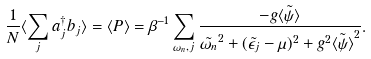<formula> <loc_0><loc_0><loc_500><loc_500>\frac { 1 } { N } \langle \sum _ { j } a ^ { \dagger } _ { j } b _ { j } \rangle = \langle P \rangle = \beta ^ { - 1 } \sum _ { \omega _ { n } , j } \frac { - g \tilde { \langle \psi \rangle } } { \tilde { \omega _ { n } } ^ { 2 } + ( \tilde { \epsilon _ { j } } - \mu ) ^ { 2 } + g ^ { 2 } \tilde { \langle \psi \rangle } ^ { 2 } } .</formula> 